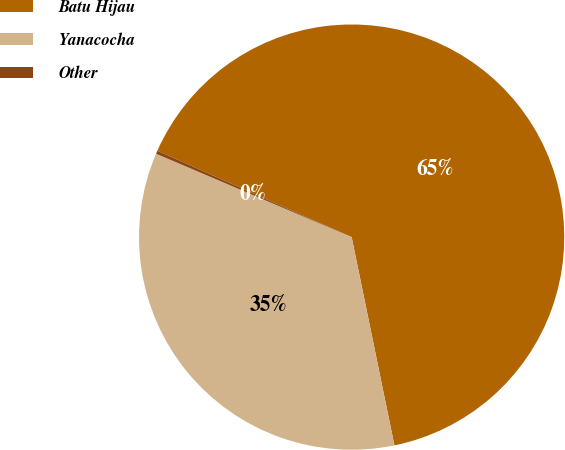Convert chart. <chart><loc_0><loc_0><loc_500><loc_500><pie_chart><fcel>Batu Hijau<fcel>Yanacocha<fcel>Other<nl><fcel>65.12%<fcel>34.64%<fcel>0.24%<nl></chart> 